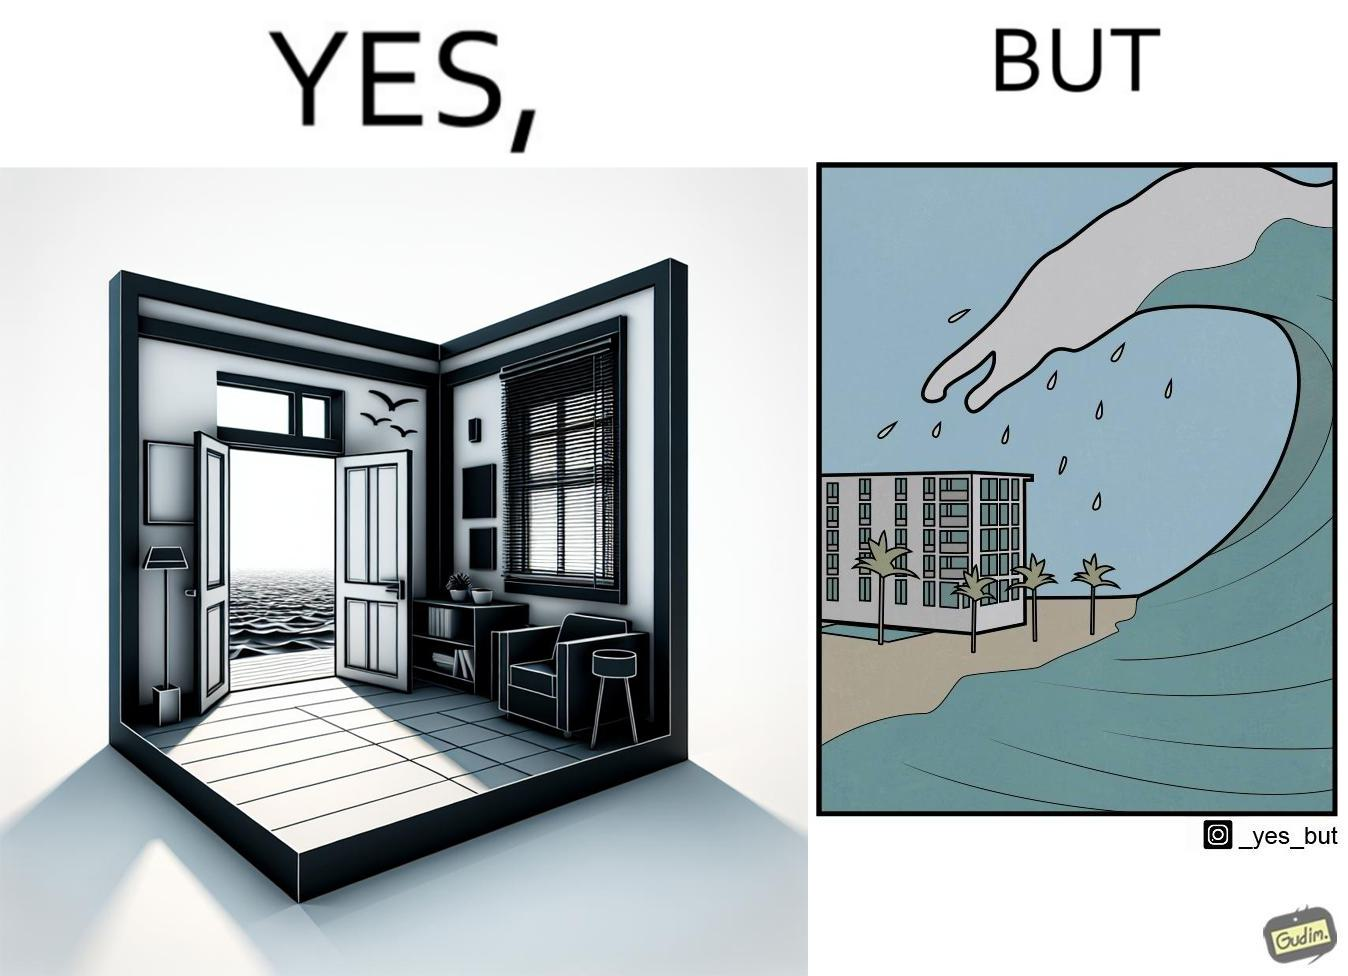What is the satirical meaning behind this image? The same sea which gives us a relaxation on a normal day can pose a danger to us sometimes like during a tsunami 